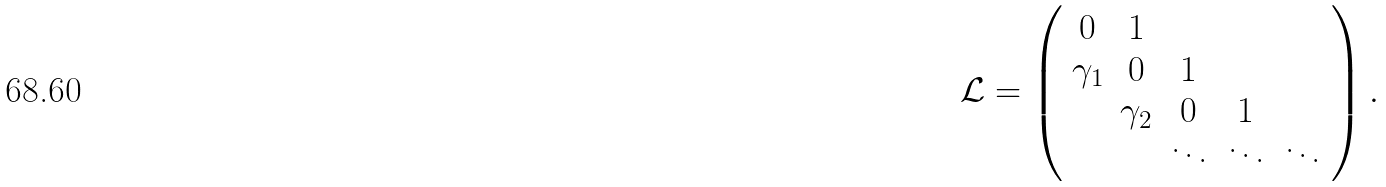Convert formula to latex. <formula><loc_0><loc_0><loc_500><loc_500>\mathcal { L } = \left ( \begin{array} { c c c c c } 0 & 1 & & & \\ \gamma _ { 1 } & 0 & 1 & & \\ & \gamma _ { 2 } & 0 & 1 & \\ & & \ddots & \ddots & \ddots \end{array} \right ) .</formula> 